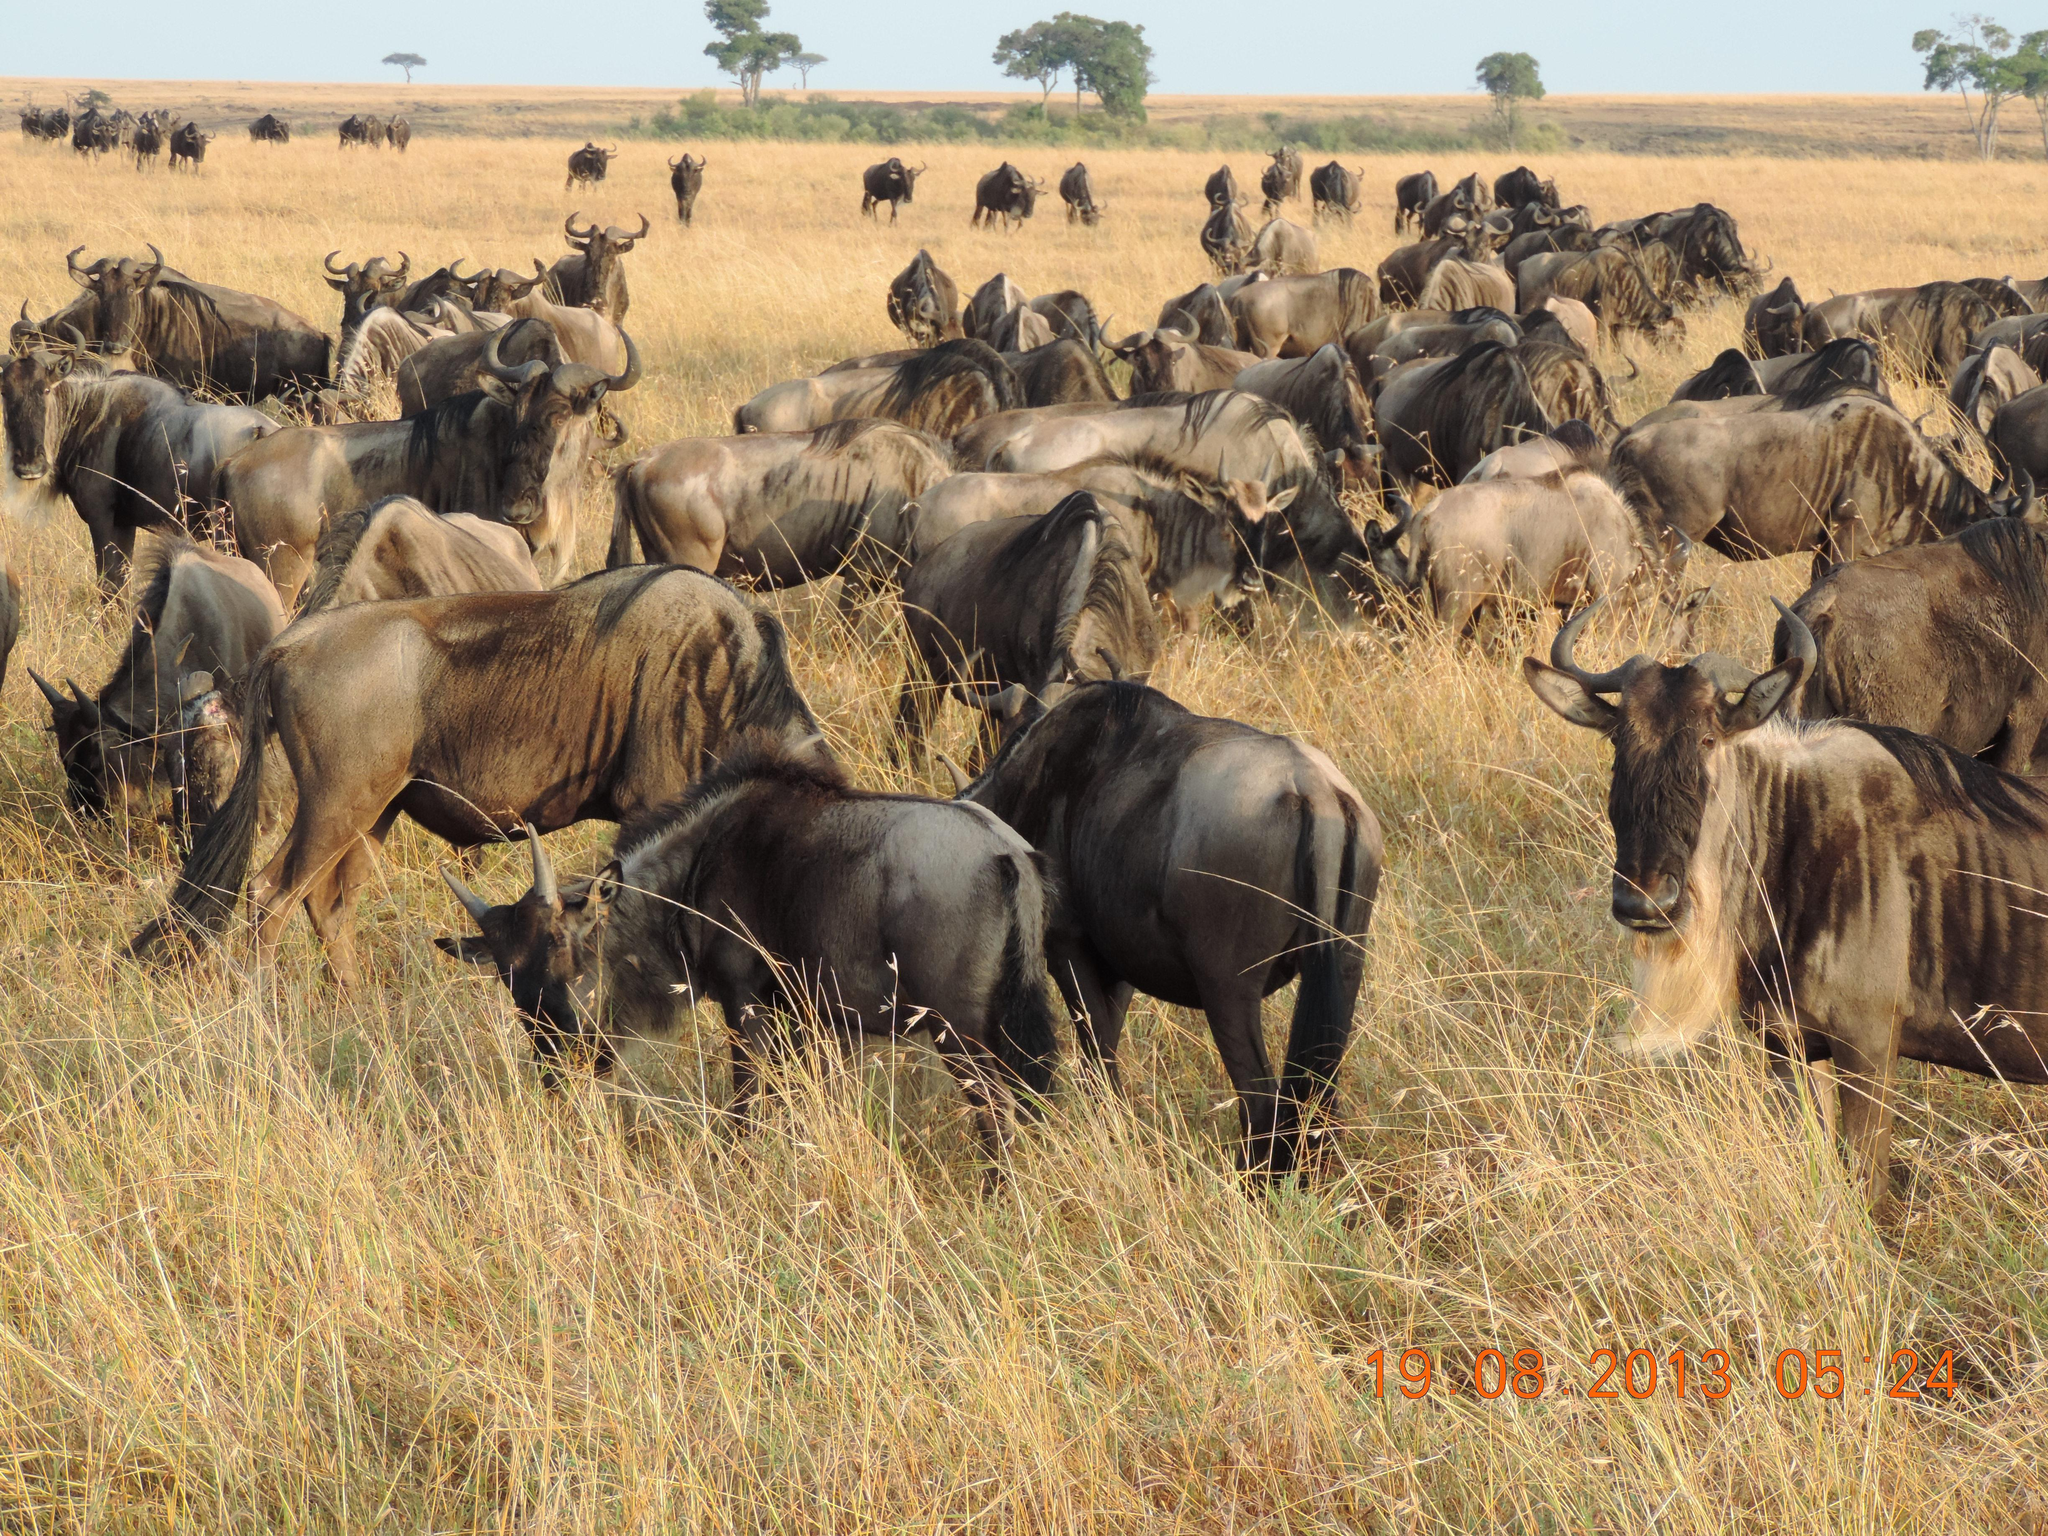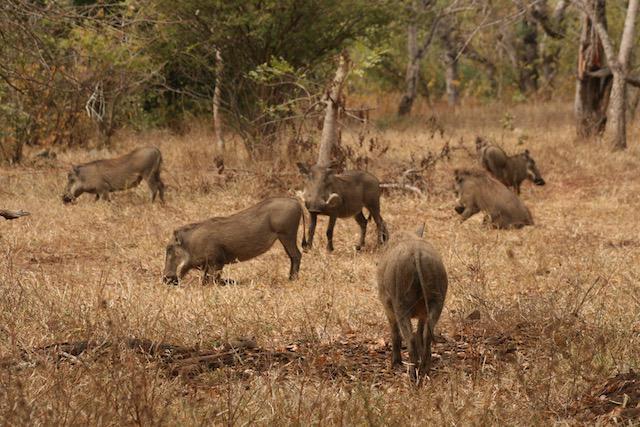The first image is the image on the left, the second image is the image on the right. Examine the images to the left and right. Is the description "Multiple zebra are standing behind at least one warthog in an image." accurate? Answer yes or no. No. The first image is the image on the left, the second image is the image on the right. Considering the images on both sides, is "One of the images shows a group of warthogs with a group of zebras in the background." valid? Answer yes or no. No. 